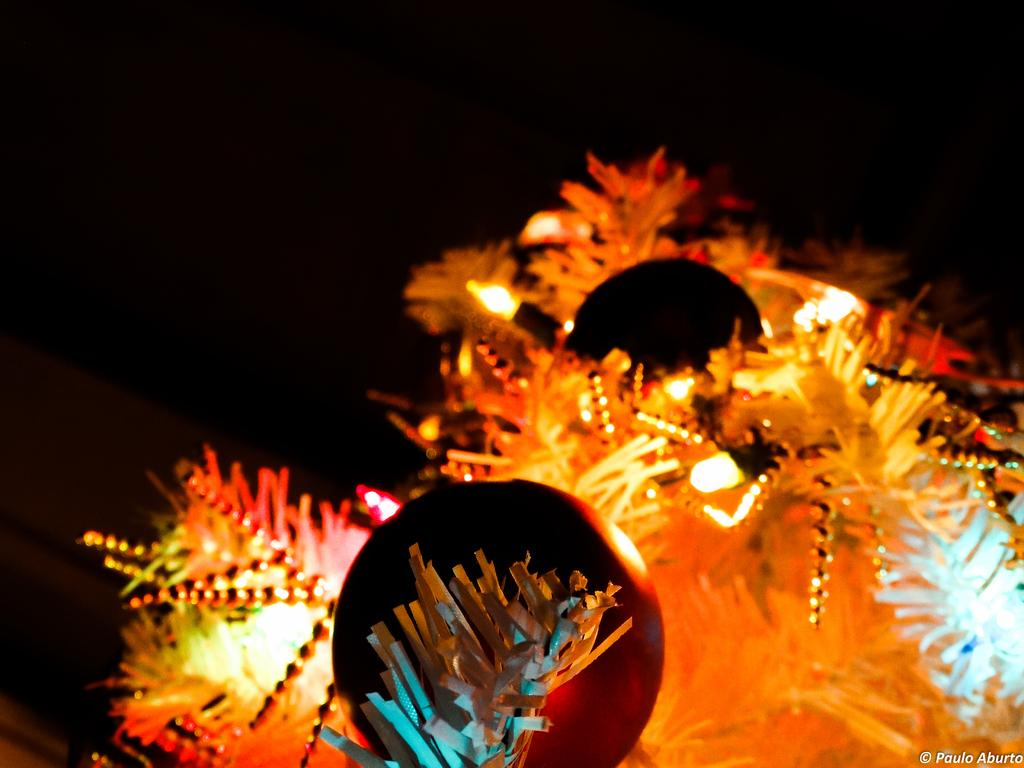What decorative items can be seen in the image? There are streamers and lights in the image. What objects are present that might be used for playing or recreation? There are balls in the image. What is written or displayed at the bottom of the image? There is text at the bottom of the image. How would you describe the overall lighting in the image? The background of the image is dark. What is the caption of the image that describes the desire of the person in the moon? There is no person in the moon, nor is there a caption in the image. The image only contains streamers, lights, balls, text, and a dark background. 